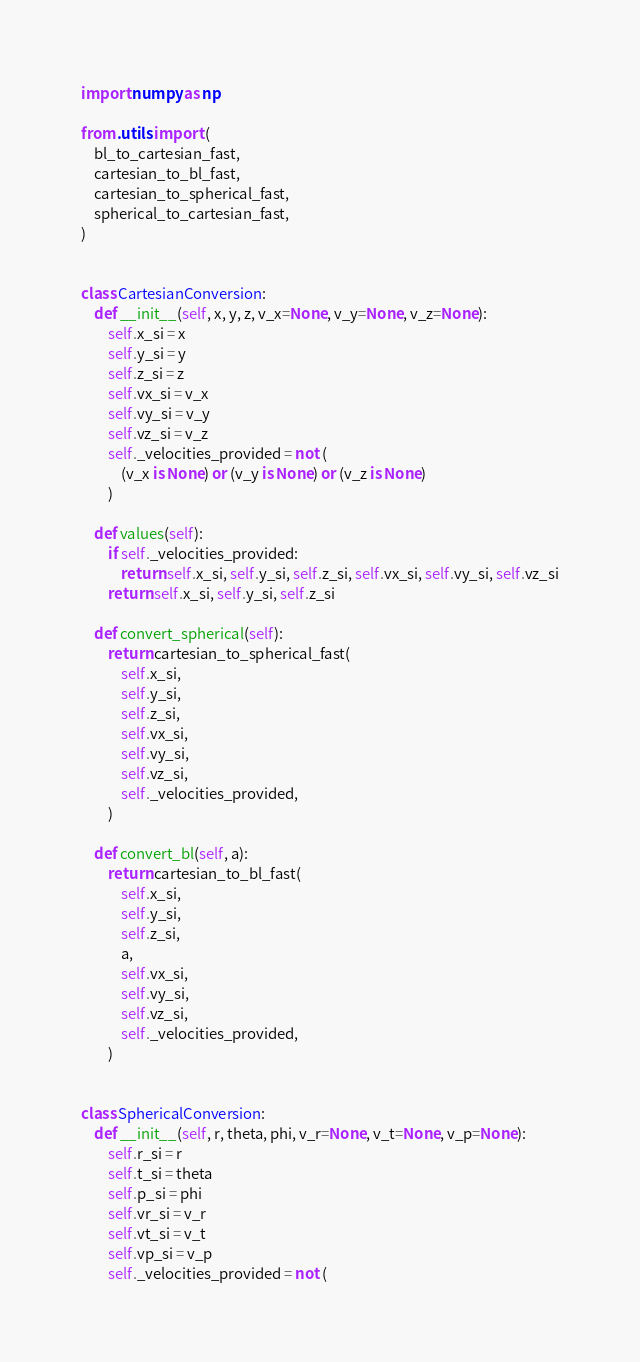Convert code to text. <code><loc_0><loc_0><loc_500><loc_500><_Python_>import numpy as np

from .utils import (
    bl_to_cartesian_fast,
    cartesian_to_bl_fast,
    cartesian_to_spherical_fast,
    spherical_to_cartesian_fast,
)


class CartesianConversion:
    def __init__(self, x, y, z, v_x=None, v_y=None, v_z=None):
        self.x_si = x
        self.y_si = y
        self.z_si = z
        self.vx_si = v_x
        self.vy_si = v_y
        self.vz_si = v_z
        self._velocities_provided = not (
            (v_x is None) or (v_y is None) or (v_z is None)
        )

    def values(self):
        if self._velocities_provided:
            return self.x_si, self.y_si, self.z_si, self.vx_si, self.vy_si, self.vz_si
        return self.x_si, self.y_si, self.z_si

    def convert_spherical(self):
        return cartesian_to_spherical_fast(
            self.x_si,
            self.y_si,
            self.z_si,
            self.vx_si,
            self.vy_si,
            self.vz_si,
            self._velocities_provided,
        )

    def convert_bl(self, a):
        return cartesian_to_bl_fast(
            self.x_si,
            self.y_si,
            self.z_si,
            a,
            self.vx_si,
            self.vy_si,
            self.vz_si,
            self._velocities_provided,
        )


class SphericalConversion:
    def __init__(self, r, theta, phi, v_r=None, v_t=None, v_p=None):
        self.r_si = r
        self.t_si = theta
        self.p_si = phi
        self.vr_si = v_r
        self.vt_si = v_t
        self.vp_si = v_p
        self._velocities_provided = not (</code> 